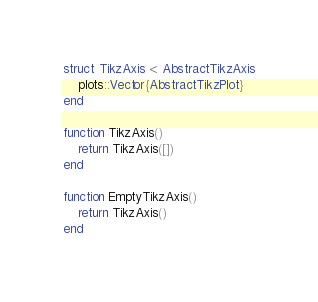<code> <loc_0><loc_0><loc_500><loc_500><_Julia_>struct TikzAxis <: AbstractTikzAxis
	plots::Vector{AbstractTikzPlot}
end

function TikzAxis()
	return TikzAxis([])
end

function EmptyTikzAxis()
	return TikzAxis()
end
</code> 